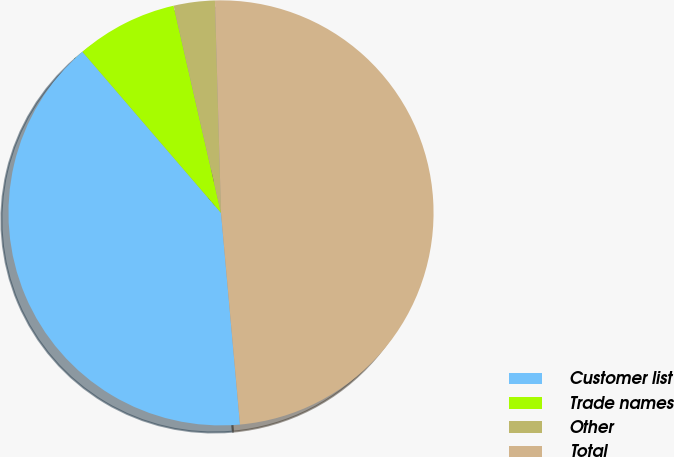Convert chart. <chart><loc_0><loc_0><loc_500><loc_500><pie_chart><fcel>Customer list<fcel>Trade names<fcel>Other<fcel>Total<nl><fcel>40.12%<fcel>7.72%<fcel>3.13%<fcel>49.03%<nl></chart> 